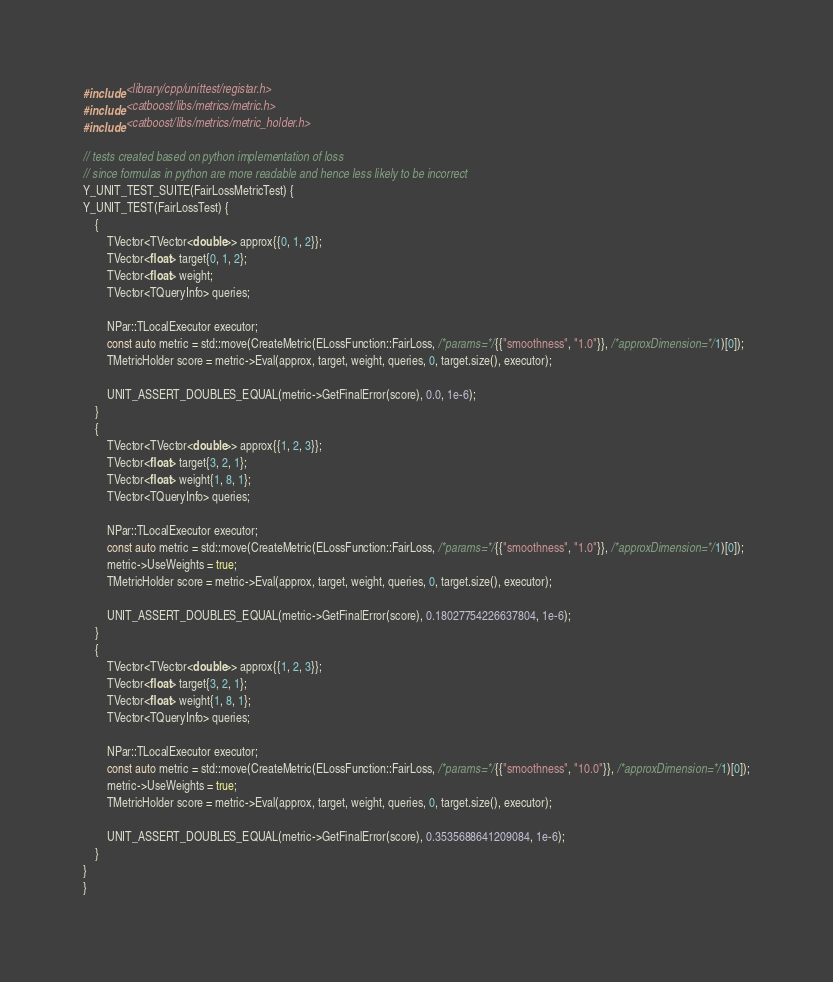<code> <loc_0><loc_0><loc_500><loc_500><_C++_>#include <library/cpp/unittest/registar.h>
#include <catboost/libs/metrics/metric.h>
#include <catboost/libs/metrics/metric_holder.h>

// tests created based on python implementation of loss
// since formulas in python are more readable and hence less likely to be incorrect
Y_UNIT_TEST_SUITE(FairLossMetricTest) {
Y_UNIT_TEST(FairLossTest) {
    {
        TVector<TVector<double>> approx{{0, 1, 2}};
        TVector<float> target{0, 1, 2};
        TVector<float> weight;
        TVector<TQueryInfo> queries;

        NPar::TLocalExecutor executor;
        const auto metric = std::move(CreateMetric(ELossFunction::FairLoss, /*params=*/{{"smoothness", "1.0"}}, /*approxDimension=*/1)[0]);
        TMetricHolder score = metric->Eval(approx, target, weight, queries, 0, target.size(), executor);

        UNIT_ASSERT_DOUBLES_EQUAL(metric->GetFinalError(score), 0.0, 1e-6);
    }
    {
        TVector<TVector<double>> approx{{1, 2, 3}};
        TVector<float> target{3, 2, 1};
        TVector<float> weight{1, 8, 1};
        TVector<TQueryInfo> queries;

        NPar::TLocalExecutor executor;
        const auto metric = std::move(CreateMetric(ELossFunction::FairLoss, /*params=*/{{"smoothness", "1.0"}}, /*approxDimension=*/1)[0]);
        metric->UseWeights = true;
        TMetricHolder score = metric->Eval(approx, target, weight, queries, 0, target.size(), executor);

        UNIT_ASSERT_DOUBLES_EQUAL(metric->GetFinalError(score), 0.18027754226637804, 1e-6);
    }
    {
        TVector<TVector<double>> approx{{1, 2, 3}};
        TVector<float> target{3, 2, 1};
        TVector<float> weight{1, 8, 1};
        TVector<TQueryInfo> queries;

        NPar::TLocalExecutor executor;
        const auto metric = std::move(CreateMetric(ELossFunction::FairLoss, /*params=*/{{"smoothness", "10.0"}}, /*approxDimension=*/1)[0]);
        metric->UseWeights = true;
        TMetricHolder score = metric->Eval(approx, target, weight, queries, 0, target.size(), executor);

        UNIT_ASSERT_DOUBLES_EQUAL(metric->GetFinalError(score), 0.3535688641209084, 1e-6);
    }
}
}
</code> 